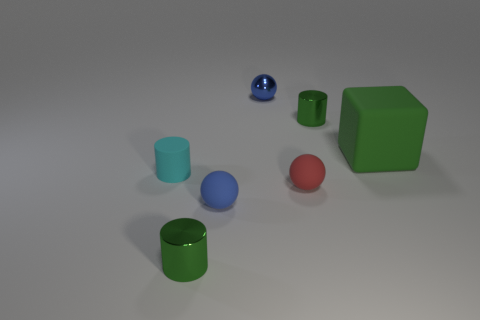There is another tiny ball that is the same color as the small shiny sphere; what material is it?
Ensure brevity in your answer.  Rubber. Is there anything else that is the same shape as the tiny cyan thing?
Make the answer very short. Yes. There is a green cylinder that is in front of the tiny blue matte thing; what is it made of?
Offer a very short reply. Metal. Does the small green cylinder to the right of the blue rubber ball have the same material as the big green block?
Your answer should be compact. No. How many objects are either tiny red things or green cylinders that are in front of the cyan thing?
Offer a very short reply. 2. What is the size of the blue shiny object that is the same shape as the blue matte thing?
Offer a terse response. Small. Is there anything else that has the same size as the blue metallic thing?
Give a very brief answer. Yes. There is a red thing; are there any small green shiny cylinders on the right side of it?
Provide a short and direct response. Yes. Does the small metallic thing in front of the small cyan cylinder have the same color as the small cylinder behind the tiny cyan thing?
Provide a short and direct response. Yes. Is there a tiny cyan metallic object that has the same shape as the red rubber object?
Your answer should be very brief. No. 